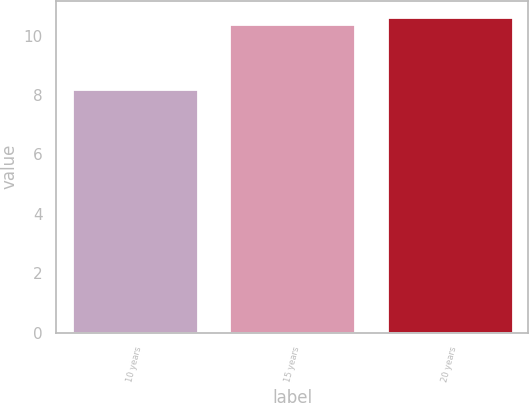<chart> <loc_0><loc_0><loc_500><loc_500><bar_chart><fcel>10 years<fcel>15 years<fcel>20 years<nl><fcel>8.2<fcel>10.4<fcel>10.64<nl></chart> 